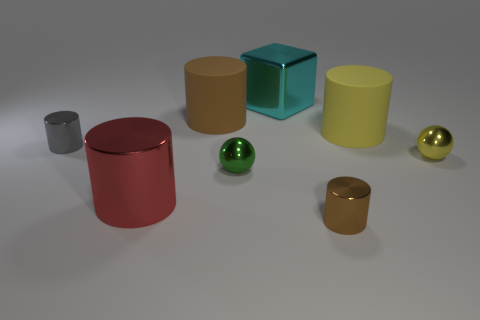Subtract all purple cubes. How many brown cylinders are left? 2 Subtract all gray metal cylinders. How many cylinders are left? 4 Add 1 shiny objects. How many objects exist? 9 Subtract 3 cylinders. How many cylinders are left? 2 Subtract all gray cylinders. How many cylinders are left? 4 Subtract all yellow cylinders. Subtract all gray spheres. How many cylinders are left? 4 Subtract all spheres. How many objects are left? 6 Subtract all green metallic cubes. Subtract all small gray cylinders. How many objects are left? 7 Add 3 metallic balls. How many metallic balls are left? 5 Add 1 big brown cylinders. How many big brown cylinders exist? 2 